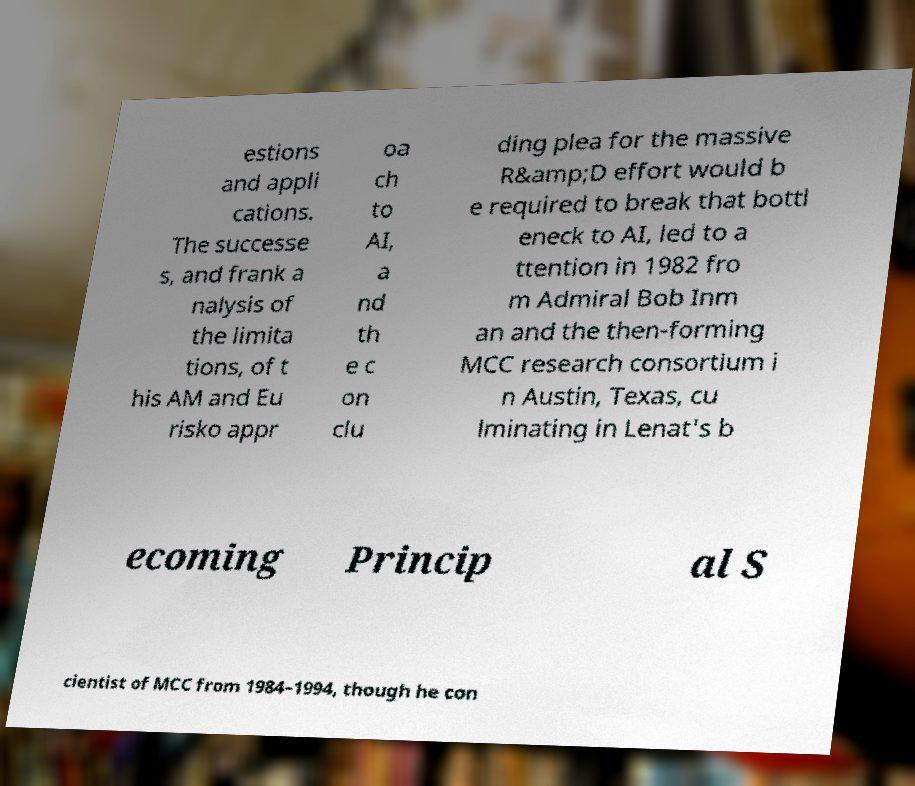Could you assist in decoding the text presented in this image and type it out clearly? estions and appli cations. The successe s, and frank a nalysis of the limita tions, of t his AM and Eu risko appr oa ch to AI, a nd th e c on clu ding plea for the massive R&amp;D effort would b e required to break that bottl eneck to AI, led to a ttention in 1982 fro m Admiral Bob Inm an and the then-forming MCC research consortium i n Austin, Texas, cu lminating in Lenat's b ecoming Princip al S cientist of MCC from 1984–1994, though he con 